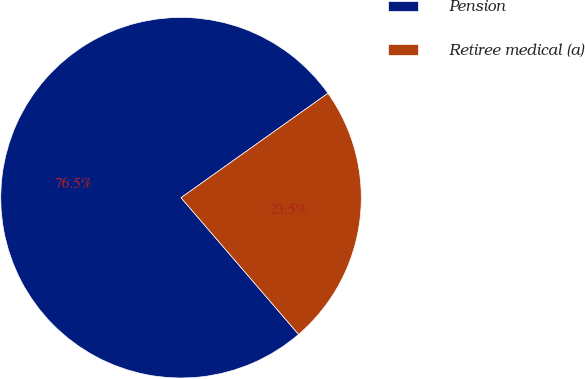Convert chart. <chart><loc_0><loc_0><loc_500><loc_500><pie_chart><fcel>Pension<fcel>Retiree medical (a)<nl><fcel>76.47%<fcel>23.53%<nl></chart> 